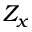<formula> <loc_0><loc_0><loc_500><loc_500>Z _ { x }</formula> 